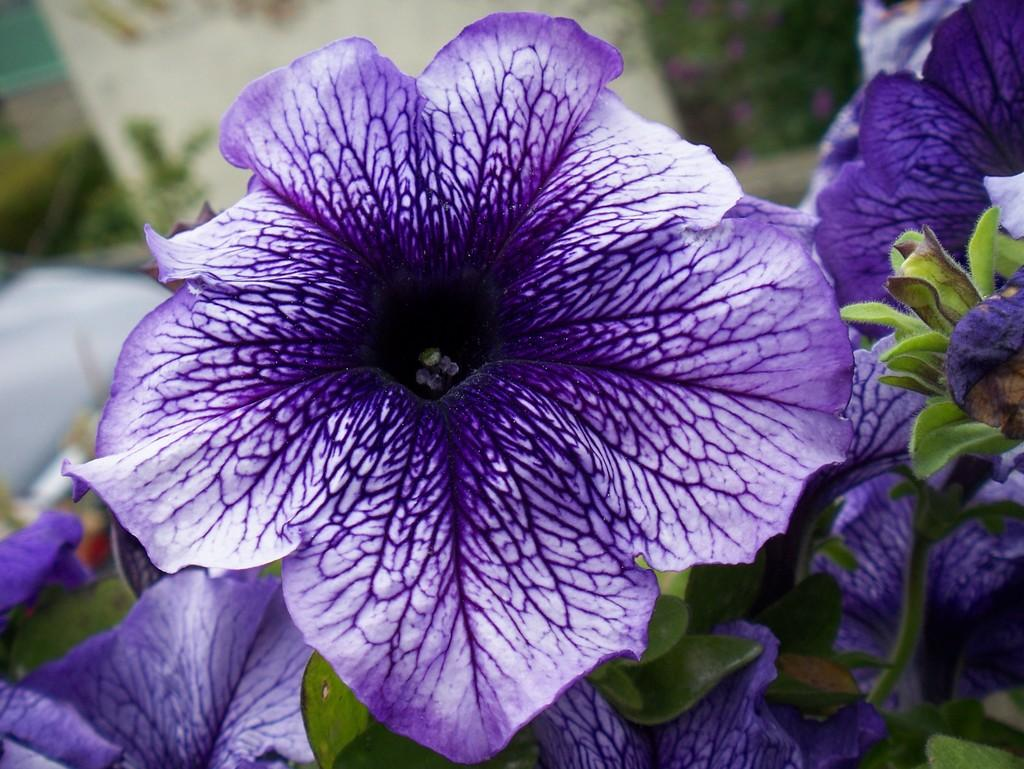What type of plant life can be seen in the image? There are flowers and leaves in the image. Can you describe the flowers in the image? Unfortunately, the facts provided do not give specific details about the flowers. Are there any other elements related to the plants in the image? No additional elements related to the plants are mentioned in the facts provided. How many letters can be seen on the leaves in the image? There are no letters present on the leaves in the image. What type of lettuce is visible in the image? There is no lettuce present in the image; it features flowers and leaves. 